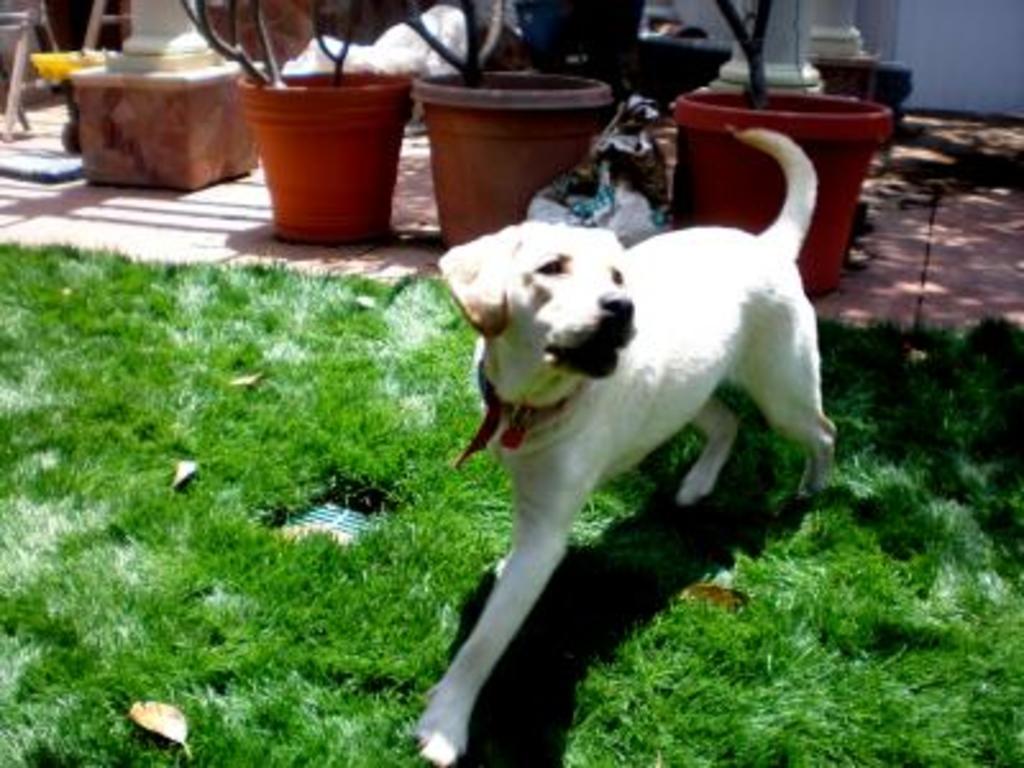Can you describe this image briefly? There is a white dog on the grass lawn. In the back there are pots with plants. Also there are some other items in the background. 